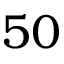<formula> <loc_0><loc_0><loc_500><loc_500>5 0</formula> 